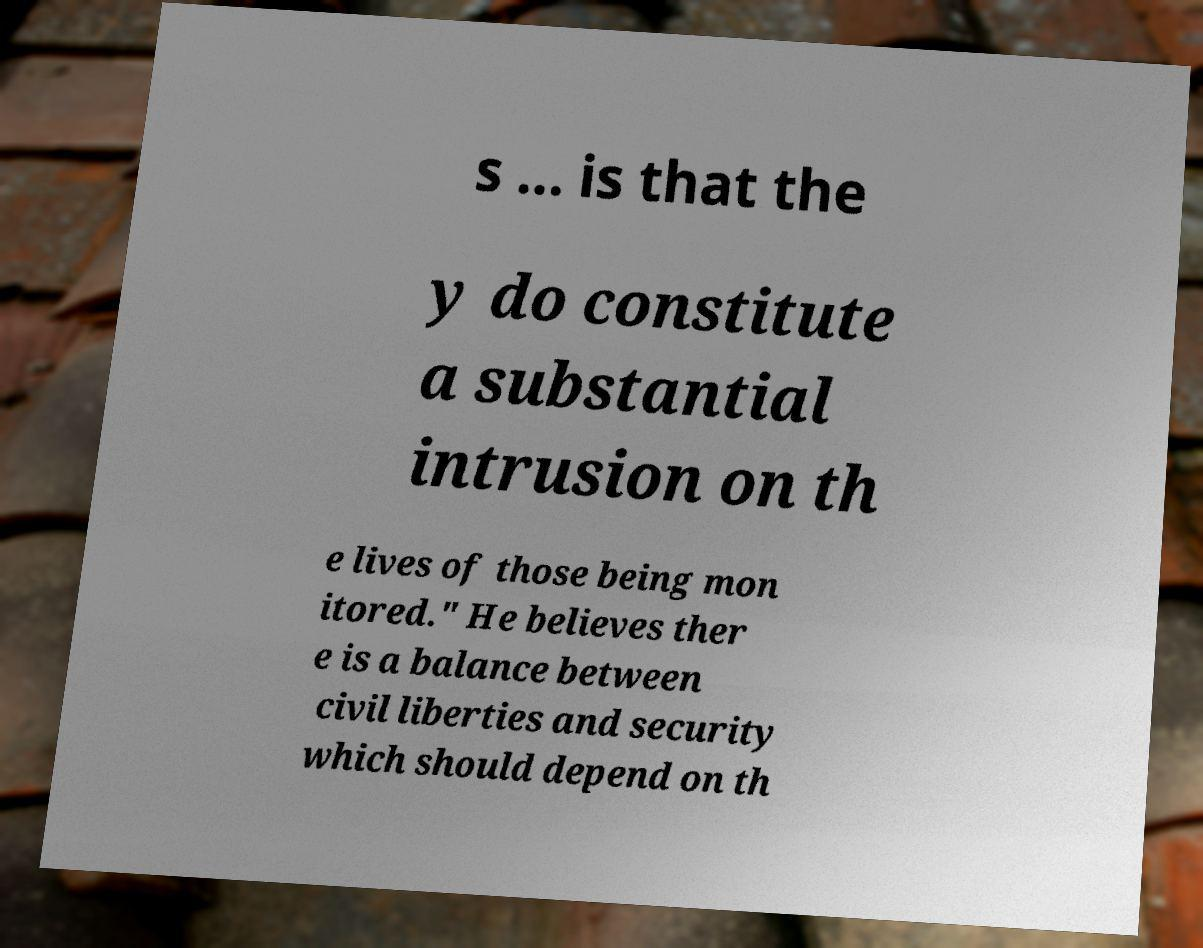Could you extract and type out the text from this image? s ... is that the y do constitute a substantial intrusion on th e lives of those being mon itored." He believes ther e is a balance between civil liberties and security which should depend on th 